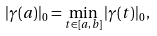Convert formula to latex. <formula><loc_0><loc_0><loc_500><loc_500>| \gamma ( a ) | _ { 0 } = \min _ { t \in [ a , b ] } | \gamma ( t ) | _ { 0 } ,</formula> 